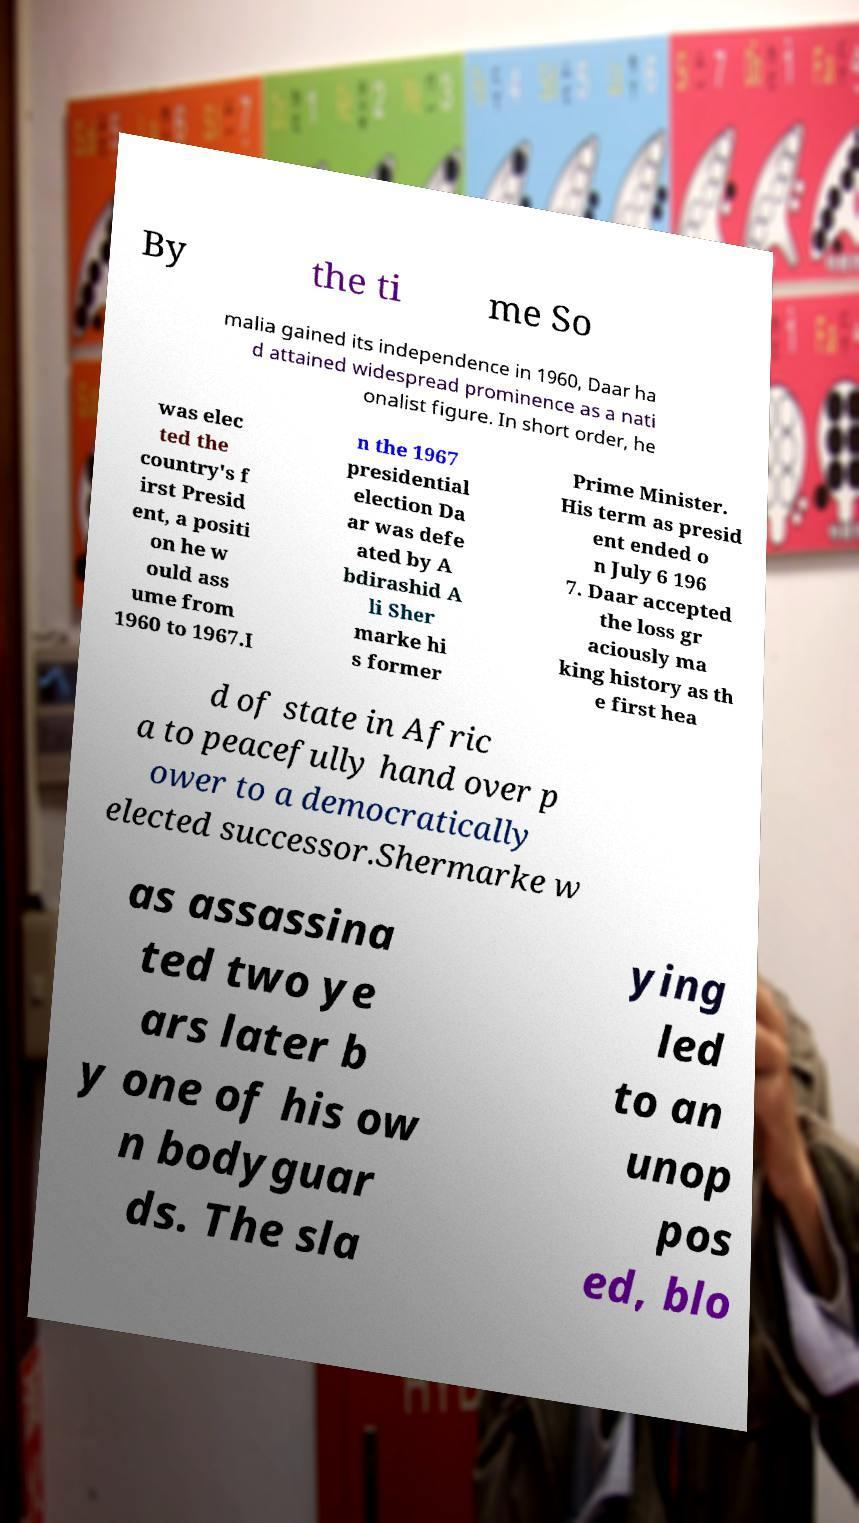Can you read and provide the text displayed in the image?This photo seems to have some interesting text. Can you extract and type it out for me? By the ti me So malia gained its independence in 1960, Daar ha d attained widespread prominence as a nati onalist figure. In short order, he was elec ted the country's f irst Presid ent, a positi on he w ould ass ume from 1960 to 1967.I n the 1967 presidential election Da ar was defe ated by A bdirashid A li Sher marke hi s former Prime Minister. His term as presid ent ended o n July 6 196 7. Daar accepted the loss gr aciously ma king history as th e first hea d of state in Afric a to peacefully hand over p ower to a democratically elected successor.Shermarke w as assassina ted two ye ars later b y one of his ow n bodyguar ds. The sla ying led to an unop pos ed, blo 